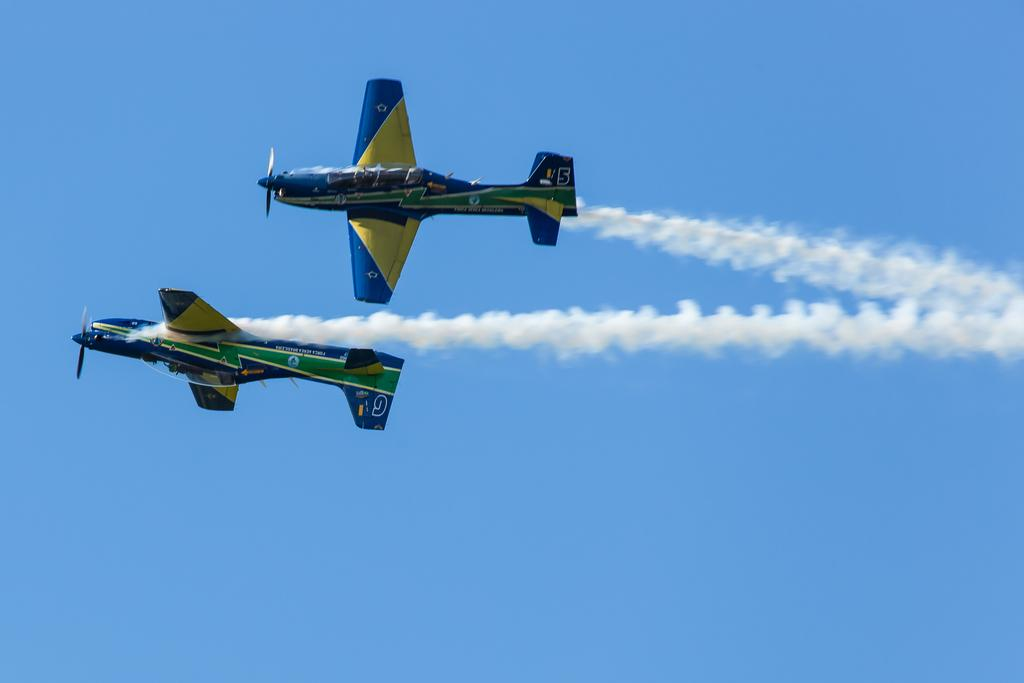What is the main subject of the image? The main subject of the image is two planes. Where are the planes located in the image? The planes are in the middle of the image. What can be seen in the background of the image? There is sky visible behind the planes. What type of development can be seen taking place near the planes in the image? There is no development visible in the image; the image only shows two planes and sky in the background. 